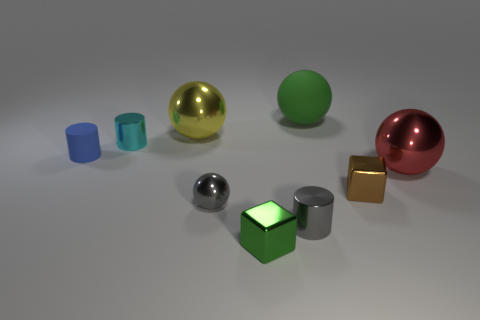Is there any other thing that has the same size as the blue thing?
Your answer should be compact. Yes. The big ball left of the metal cylinder in front of the big red sphere is what color?
Your response must be concise. Yellow. What color is the other large matte object that is the same shape as the red object?
Ensure brevity in your answer.  Green. How many large metallic objects have the same color as the small matte object?
Your answer should be very brief. 0. Do the matte sphere and the tiny thing that is behind the rubber cylinder have the same color?
Offer a terse response. No. The tiny shiny object that is behind the small gray cylinder and in front of the brown thing has what shape?
Offer a terse response. Sphere. The green object behind the gray thing that is left of the block on the left side of the large green matte ball is made of what material?
Offer a terse response. Rubber. Is the number of red balls that are left of the small cyan metallic thing greater than the number of tiny shiny blocks that are to the right of the tiny brown shiny object?
Keep it short and to the point. No. How many cubes are made of the same material as the gray sphere?
Provide a succinct answer. 2. There is a matte thing to the right of the large yellow shiny ball; is it the same shape as the big metallic object to the right of the large yellow metal sphere?
Keep it short and to the point. Yes. 